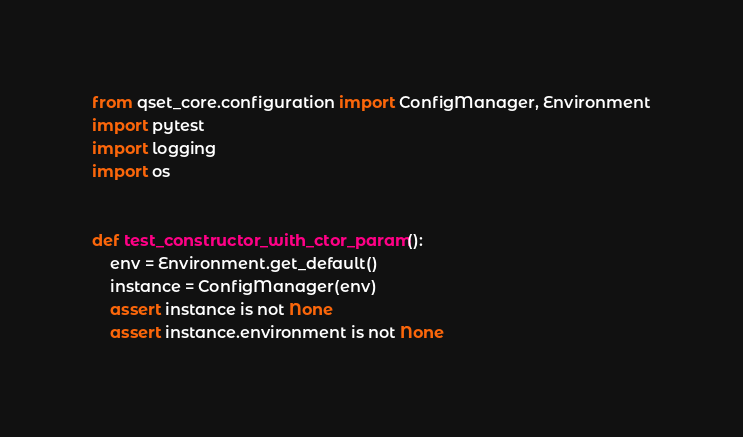Convert code to text. <code><loc_0><loc_0><loc_500><loc_500><_Python_>from qset_core.configuration import ConfigManager, Environment
import pytest
import logging
import os


def test_constructor_with_ctor_param():
    env = Environment.get_default()
    instance = ConfigManager(env)
    assert instance is not None
    assert instance.environment is not None</code> 